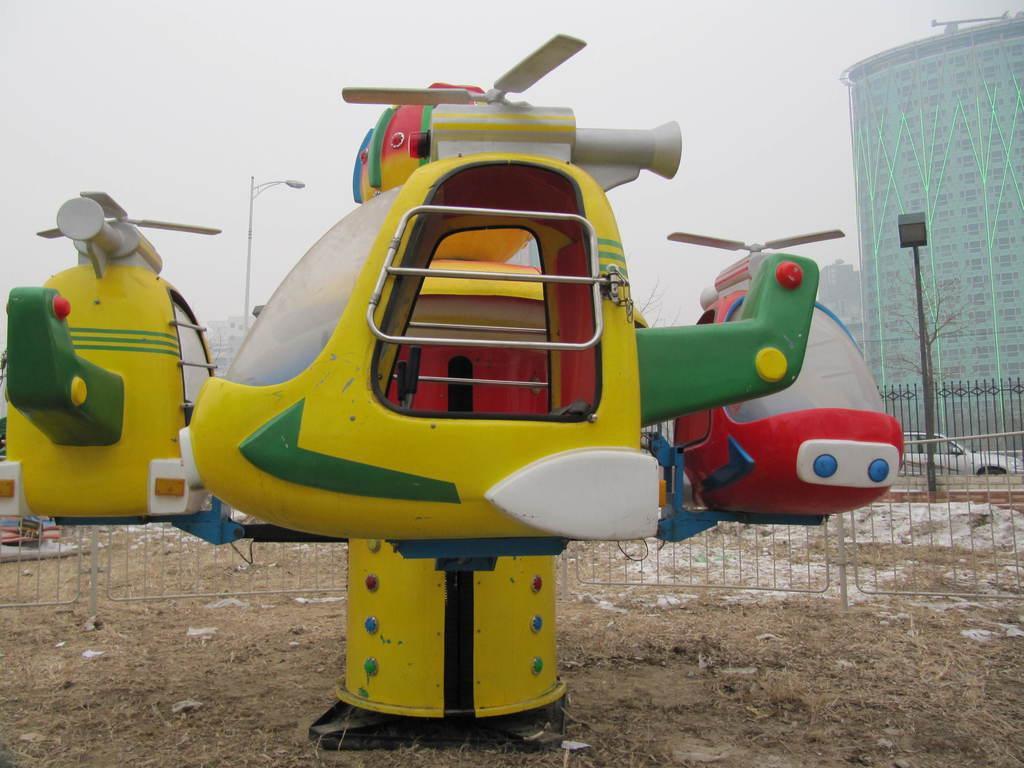Can you describe this image briefly? In this picture we can see toy vehicles on the ground, here we can see a fence, electric poles, vehicle, buildings and we can see sky in the background. 